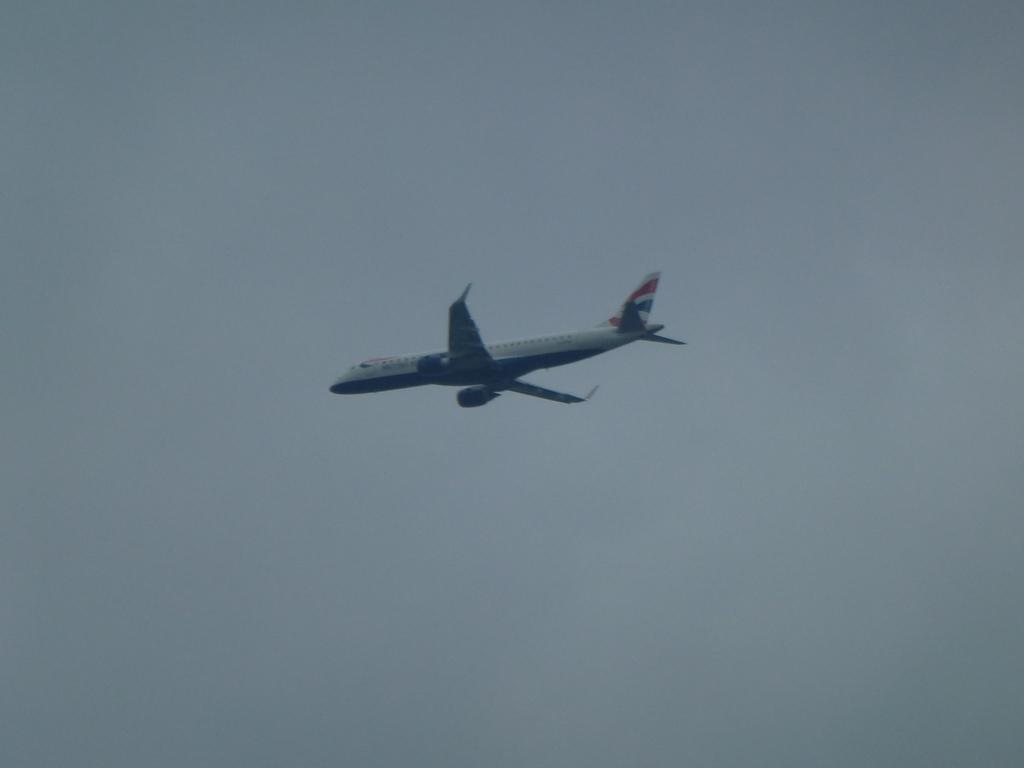What is the main subject of the image? The main subject of the image is a passenger plane. What is the plane doing in the image? The plane is flying in the air. What can be seen in the background of the image? The sky is visible in the image. Are there any weather conditions depicted in the image? Yes, clouds are present in the sky. What type of blade is being used by the secretary in the image? There is no secretary or blade present in the image; it features a passenger plane flying in the sky. 